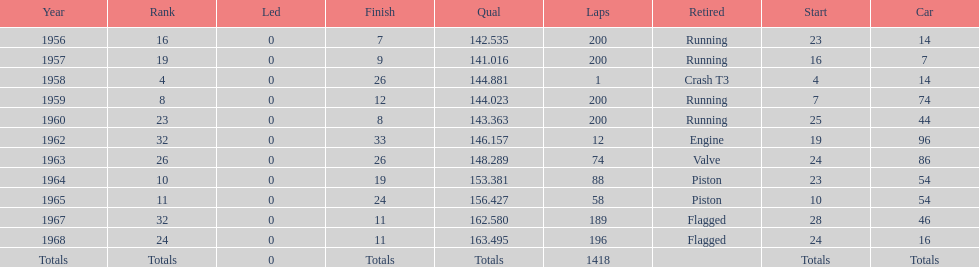How many times did he finish all 200 laps? 4. 